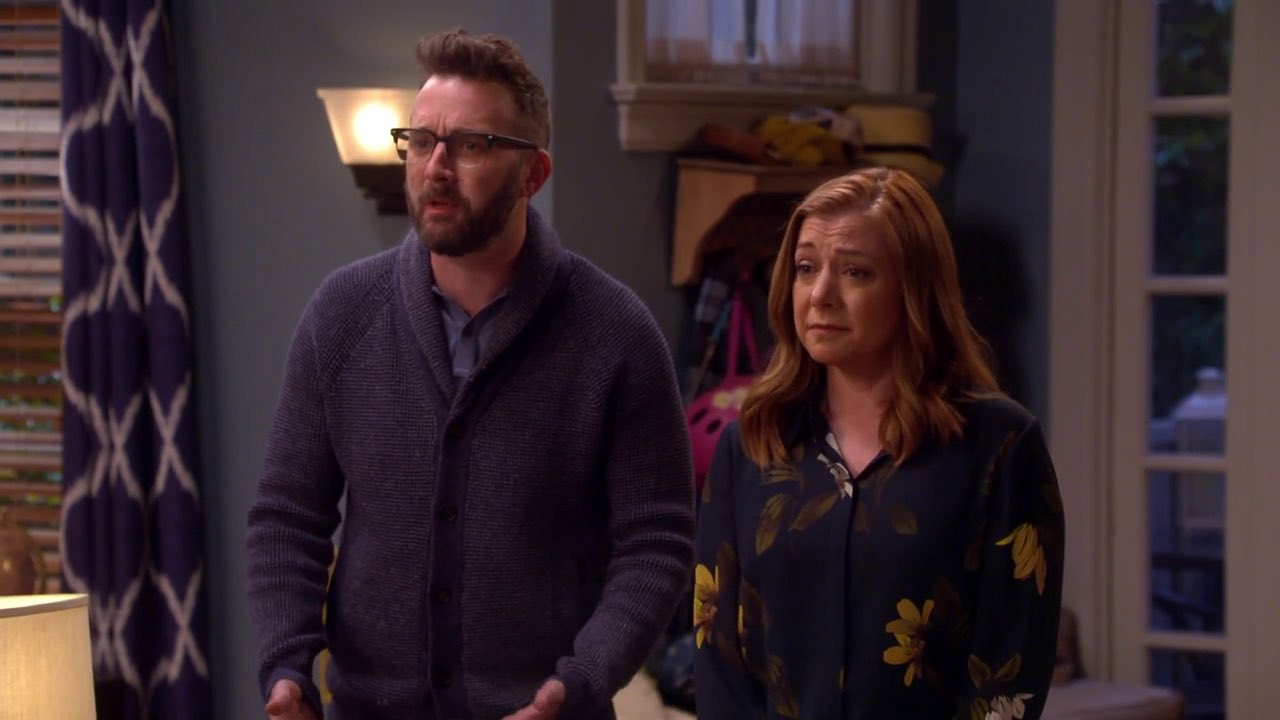What is this photo about'? The image shows two individuals, a man and a woman, standing in a living room setting. The man on the left is dressed in a blue cardigan and glasses, and appears to be concerned as he directs his gaze off to the left. The woman on the right is wearing a blue floral dress, sharing a similar concerned expression and also looking towards the sharegpt4v/same direction. The scene suggests a moment of shared worry or apprehension within a domestic environment. 